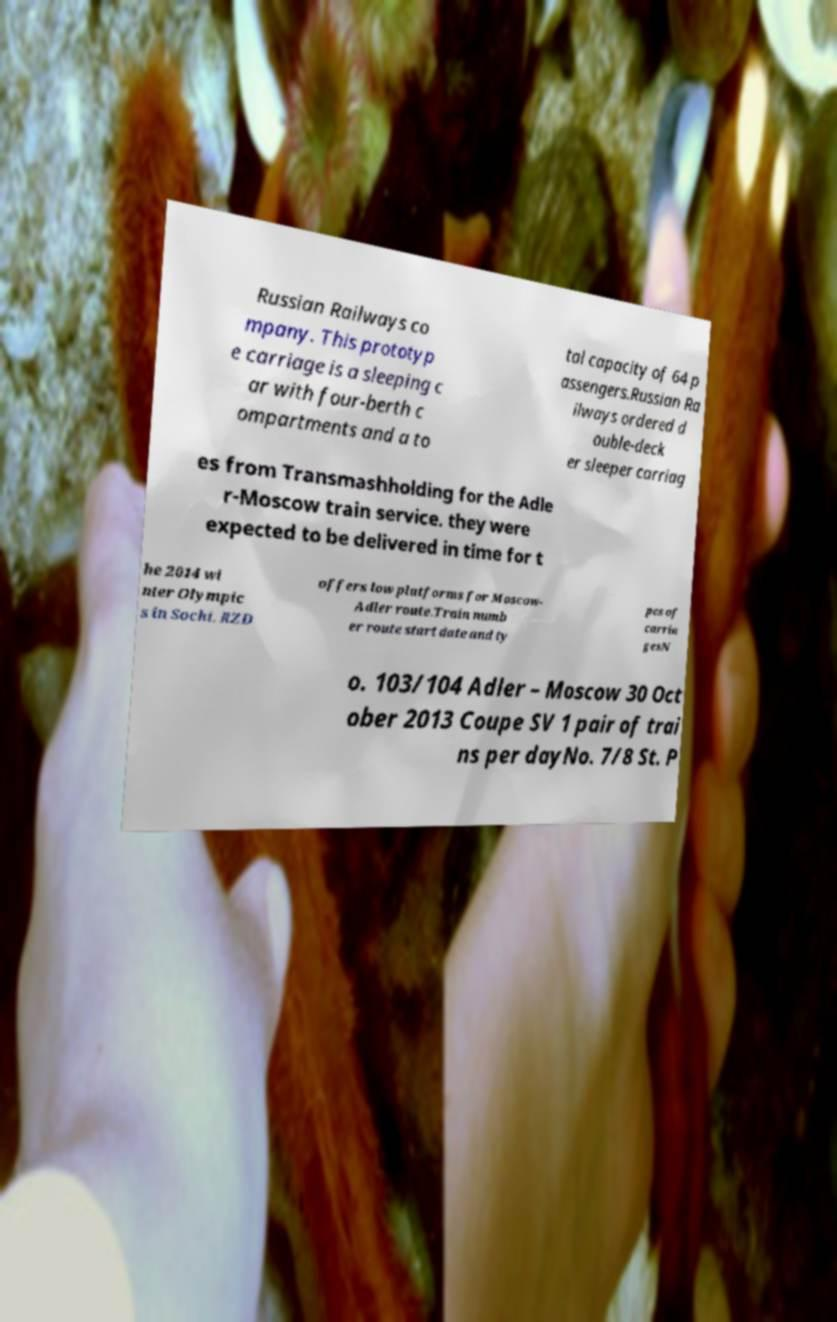Please identify and transcribe the text found in this image. Russian Railways co mpany. This prototyp e carriage is a sleeping c ar with four-berth c ompartments and a to tal capacity of 64 p assengers.Russian Ra ilways ordered d ouble-deck er sleeper carriag es from Transmashholding for the Adle r-Moscow train service. they were expected to be delivered in time for t he 2014 wi nter Olympic s in Sochi. RZD offers low platforms for Moscow- Adler route.Train numb er route start date and ty pes of carria gesN o. 103/104 Adler – Moscow 30 Oct ober 2013 Coupe SV 1 pair of trai ns per dayNo. 7/8 St. P 